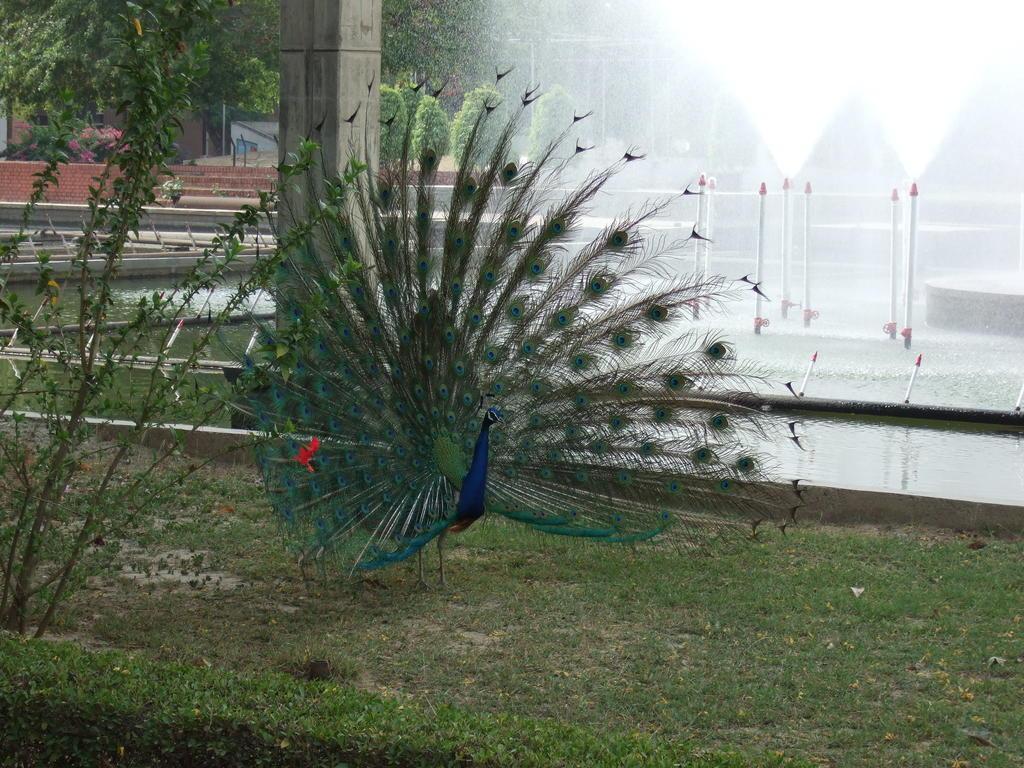Could you give a brief overview of what you see in this image? In this image we can see a peacock on the ground. On the left side of the image we can see some flowers on the plants, pillar and some trees. On the right side of the image we can see grass and fountain. 